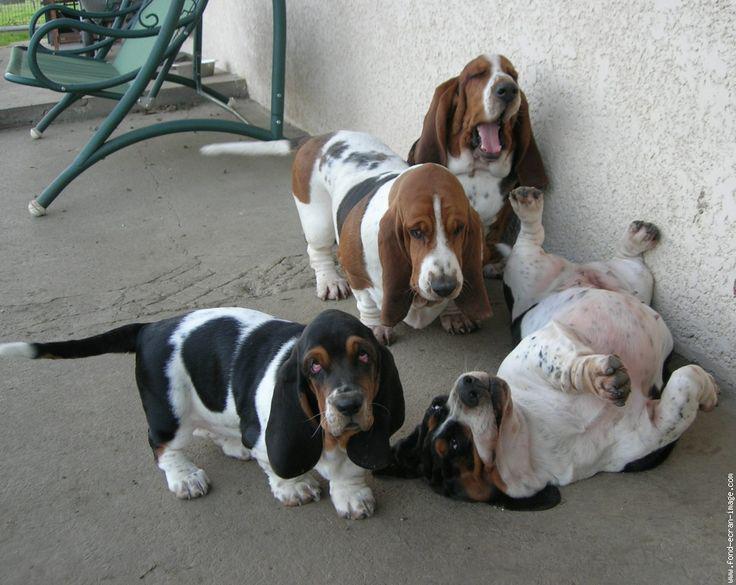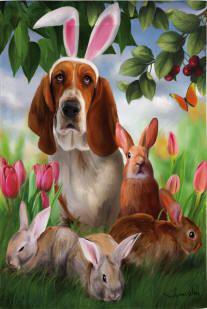The first image is the image on the left, the second image is the image on the right. Examine the images to the left and right. Is the description "there is only one dog in the image on the left side and it is not wearing bunny ears." accurate? Answer yes or no. No. The first image is the image on the left, the second image is the image on the right. Examine the images to the left and right. Is the description "A real basset hound is wearing rabbit hears." accurate? Answer yes or no. No. 